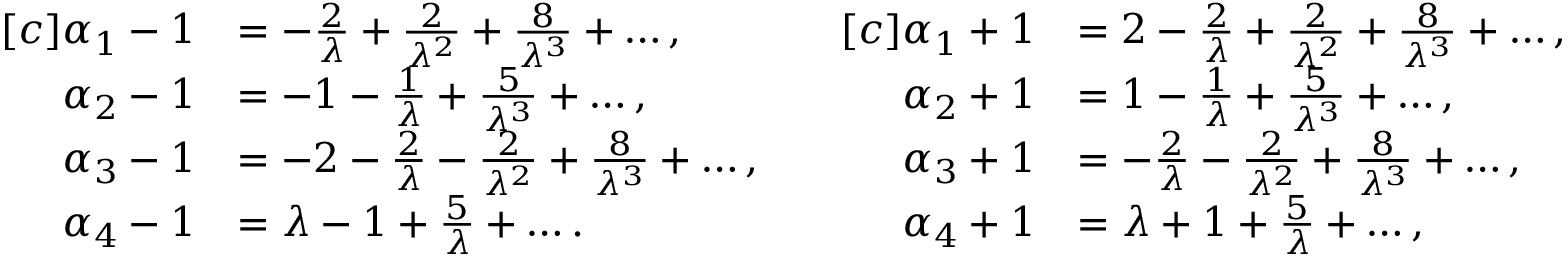Convert formula to latex. <formula><loc_0><loc_0><loc_500><loc_500>\begin{array} { r l } { [ c ] \alpha _ { 1 } - 1 } & { = - \frac { 2 } { \lambda } + \frac { 2 } { \lambda ^ { 2 } } + \frac { 8 } { \lambda ^ { 3 } } + \dots , } \\ { \alpha _ { 2 } - 1 } & { = - 1 - \frac { 1 } { \lambda } + \frac { 5 } { \lambda ^ { 3 } } + \dots , } \\ { \alpha _ { 3 } - 1 } & { = - 2 - \frac { 2 } { \lambda } - \frac { 2 } { \lambda ^ { 2 } } + \frac { 8 } { \lambda ^ { 3 } } + \dots , } \\ { \alpha _ { 4 } - 1 } & { = \lambda - 1 + \frac { 5 } { \lambda } + \dots . } \end{array} \quad \begin{array} { r l } { [ c ] \alpha _ { 1 } + 1 } & { = 2 - \frac { 2 } { \lambda } + \frac { 2 } { \lambda ^ { 2 } } + \frac { 8 } { \lambda ^ { 3 } } + \dots , } \\ { \alpha _ { 2 } + 1 } & { = 1 - \frac { 1 } { \lambda } + \frac { 5 } { \lambda ^ { 3 } } + \dots , } \\ { \alpha _ { 3 } + 1 } & { = - \frac { 2 } { \lambda } - \frac { 2 } { \lambda ^ { 2 } } + \frac { 8 } { \lambda ^ { 3 } } + \dots , } \\ { \alpha _ { 4 } + 1 } & { = \lambda + 1 + \frac { 5 } { \lambda } + \dots , } \end{array}</formula> 